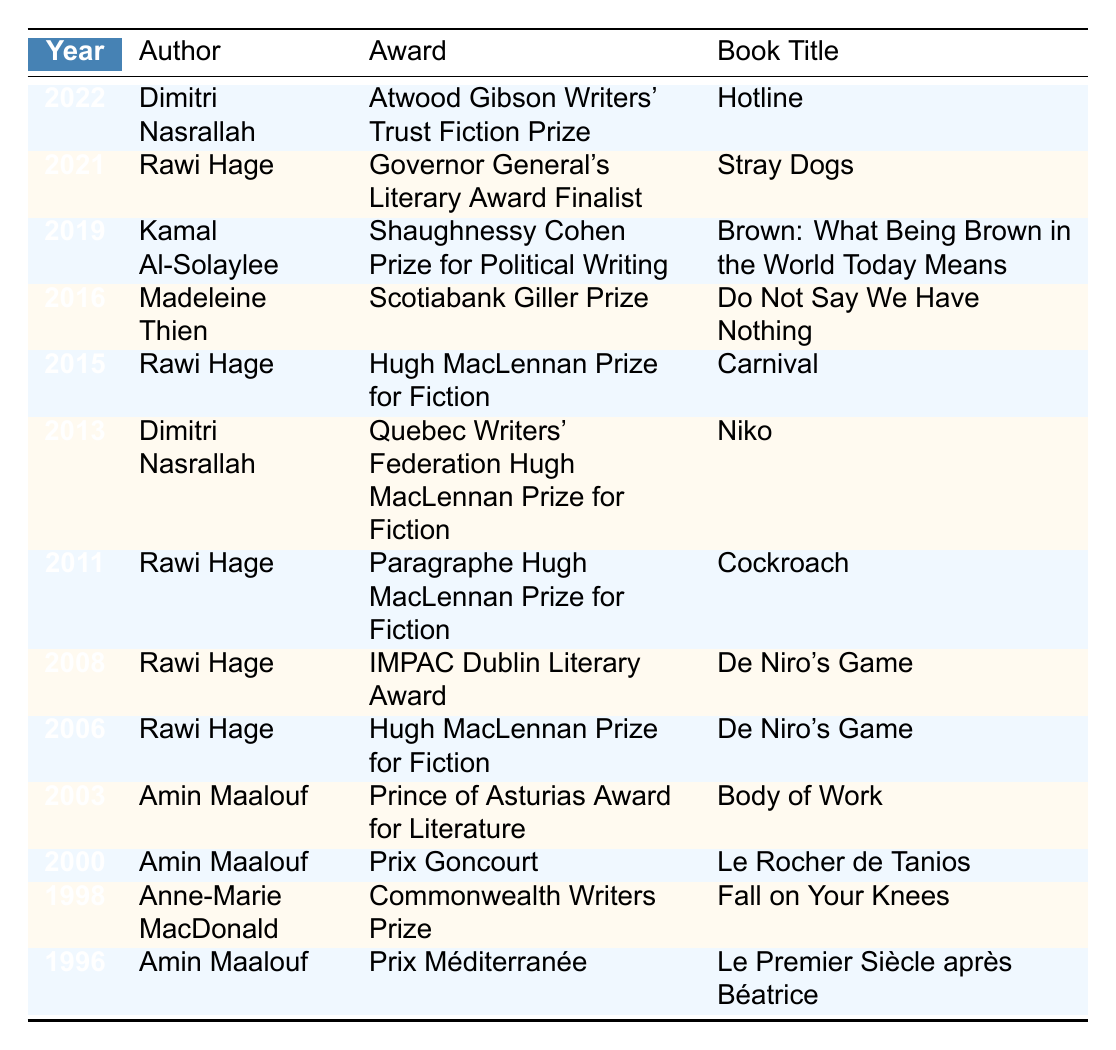What award did Dimitri Nasrallah win in 2022? According to the table, Dimitri Nasrallah won the Atwood Gibson Writers' Trust Fiction Prize in 2022 for his book "Hotline."
Answer: Atwood Gibson Writers' Trust Fiction Prize Which author has won the Hugh MacLennan Prize for Fiction the most times? By examining the table, we can see that Rawi Hage won the Hugh MacLennan Prize for Fiction three times (2006, 2011, and 2015), making him the author with the most wins for this award.
Answer: Rawi Hage Did Amin Maalouf win any awards in the 1990s? The table shows that Amin Maalouf won the Prix Méditerranée in 1996 and the Prix Goncourt in 2000; thus, yes, he won awards in the 1990s.
Answer: Yes How many different awards were won by Rawi Hage? From the table, Rawi Hage has received five distinct awards: Governor General's Literary Award Finalist, Hugh MacLennan Prize for Fiction (three times), Paragraphe Hugh MacLennan Prize for Fiction, and the IMPAC Dublin Literary Award.
Answer: Five What is the most recent year in which an award was listed in the table? The table indicates that the most recent award listed is from the year 2022, where Dimitri Nasrallah won an award.
Answer: 2022 Which author won awards in both 1996 and 2000? The table indicates that Amin Maalouf won the Prix Méditerranée in 1996 and the Prix Goncourt in 2000, making him the author who won awards in both years.
Answer: Amin Maalouf What is the total number of awards won by the authors listed between 1996 and 2016? By counting the entries in the table from 1996 to 2016, we find there are 7 awards: Amin Maalouf (1996, 2000), Anne-Marie MacDonald (1998), Rawi Hage (2006, 2008, 2011, 2015), and Madeleine Thien (2016). Therefore, the total is 7.
Answer: 7 Is there an author who won an award for their book "Hotline"? The table indicates that Dimitri Nasrallah won the Atwood Gibson Writers' Trust Fiction Prize for his book "Hotline" in 2022, confirming that he did win an award for this book.
Answer: Yes Which book title appears with the most awards in the table? The table shows that "De Niro's Game" has been associated with two awards (the Hugh MacLennan Prize for Fiction in 2006 and the IMPAC Dublin Literary Award in 2008), making it the book with the most associated awards.
Answer: De Niro's Game In total, how many awards were won by Amin Maalouf? By reviewing the table, Amin Maalouf won three awards listed: the Prix Méditerranée in 1996, the Prix Goncourt in 2000, and the Prince of Asturias Award for Literature in 2003.
Answer: Three 